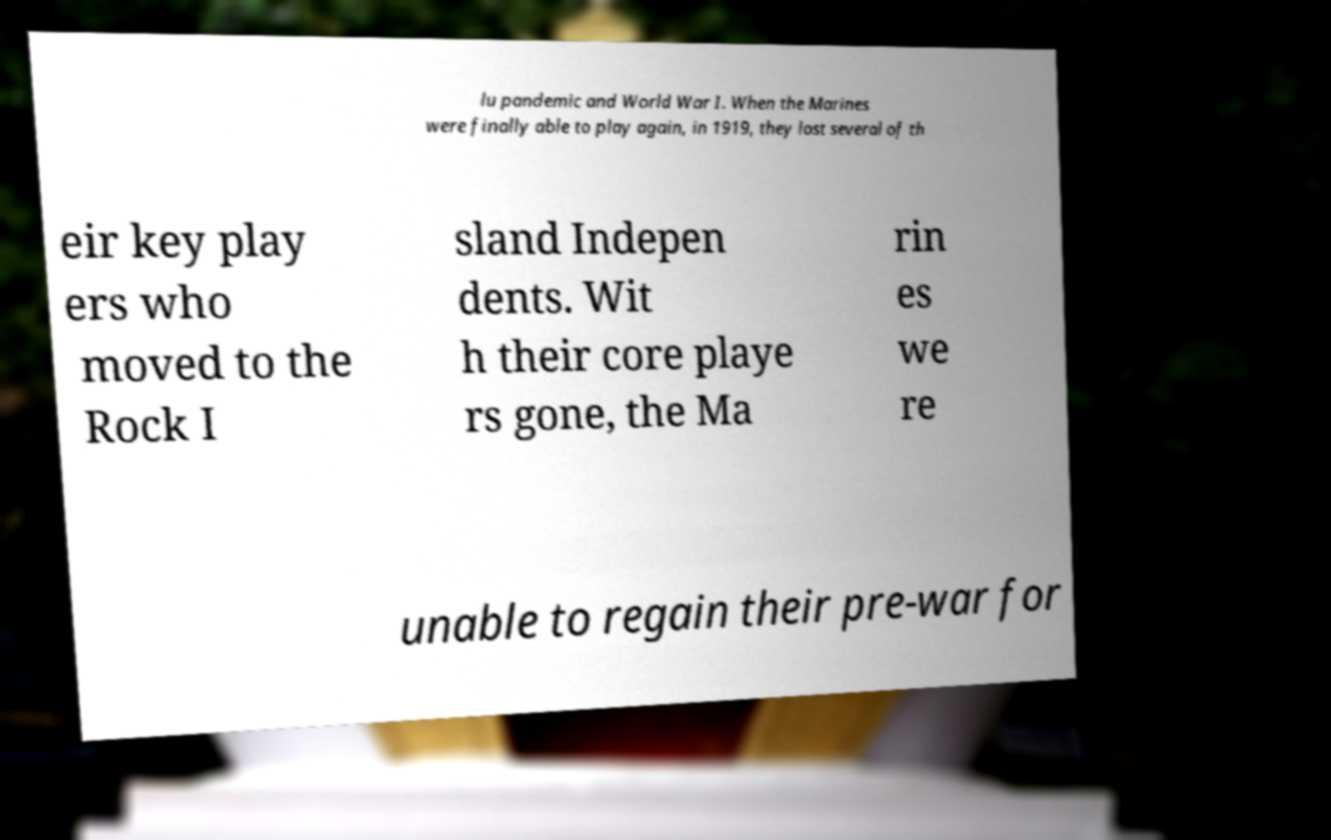Could you assist in decoding the text presented in this image and type it out clearly? lu pandemic and World War I. When the Marines were finally able to play again, in 1919, they lost several of th eir key play ers who moved to the Rock I sland Indepen dents. Wit h their core playe rs gone, the Ma rin es we re unable to regain their pre-war for 